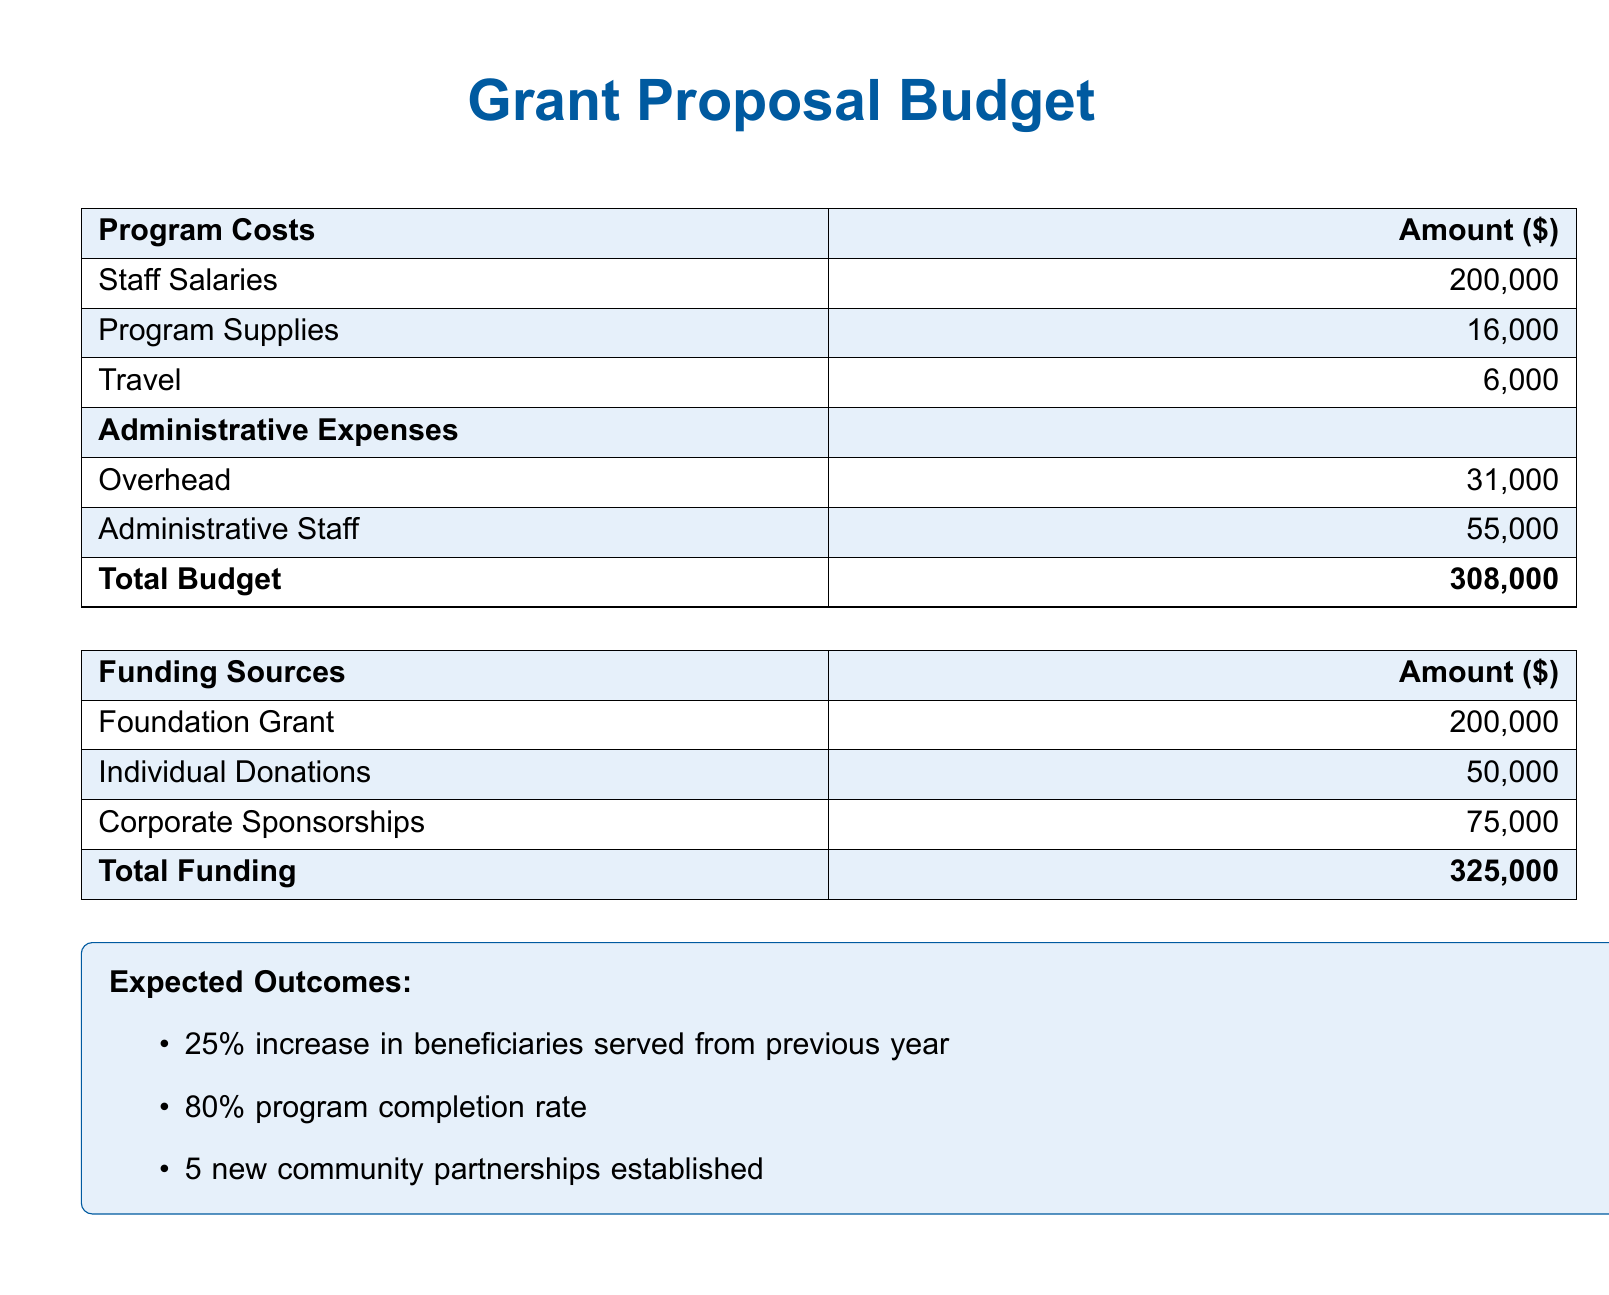What is the total program cost? The total program cost is found by summing all program costs listed in the document, which is $200,000 + $16,000 + $6,000.
Answer: $222,000 What are the administrative staff costs? The document specifies the cost for administrative staff in the administrative expenses section, which is listed as $55,000.
Answer: $55,000 How much is allocated for travel expenses? The travel expense is a specific line item under program costs, which is $6,000.
Answer: $6,000 What is the total funding amount? The total funding amount is the sum of all funding sources mentioned, which is $200,000 + $50,000 + $75,000.
Answer: $325,000 What is the expected completion rate for the program? The expected completion rate is explicitly stated in the expected outcomes section of the document, which is 80%.
Answer: 80% How many new community partnerships are expected to be established? The document lists the expected number of new community partnerships as part of the outcomes, which is 5.
Answer: 5 What is the amount for foundation grant funding? The foundation grant funding is provided in the funding sources section as $200,000.
Answer: $200,000 What percentage increase in beneficiaries is anticipated? The document specifies an anticipated increase in beneficiaries served, which is stated as 25%.
Answer: 25% 